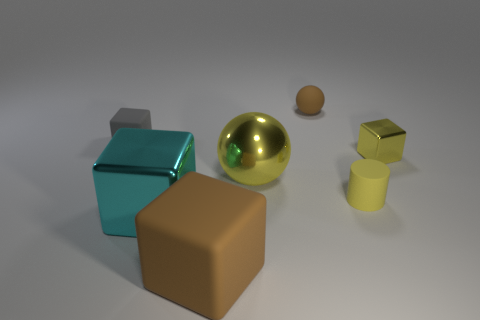Add 3 gray metallic spheres. How many objects exist? 10 Subtract all spheres. How many objects are left? 5 Add 2 gray balls. How many gray balls exist? 2 Subtract 0 red cubes. How many objects are left? 7 Subtract all big yellow metal balls. Subtract all tiny gray matte objects. How many objects are left? 5 Add 4 tiny brown matte objects. How many tiny brown matte objects are left? 5 